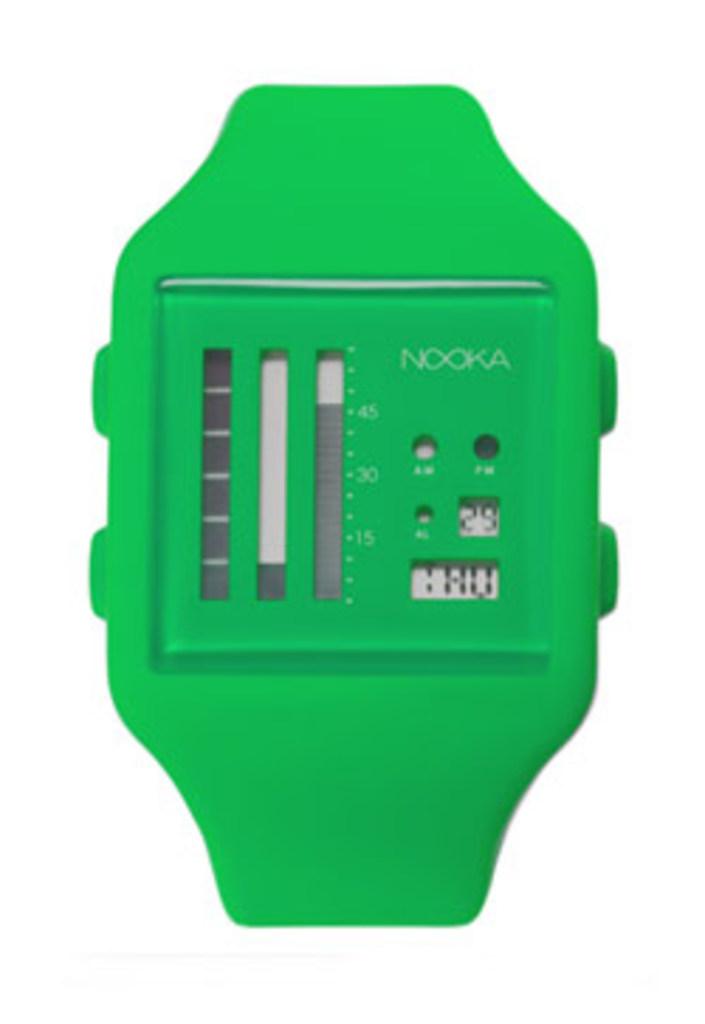What day of the week is it?
Your answer should be very brief. Thursday. What brand is the watch?
Your answer should be compact. Nooka. 